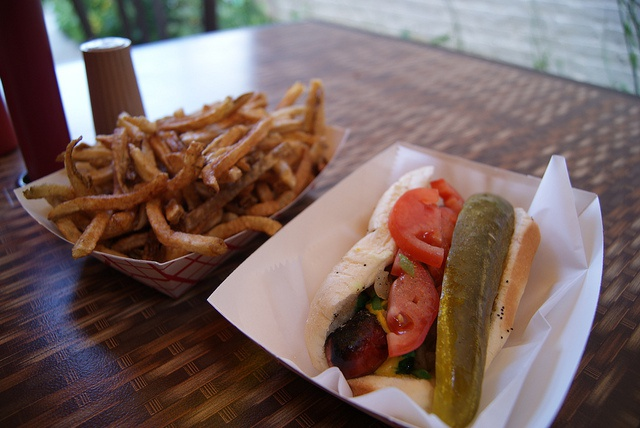Describe the objects in this image and their specific colors. I can see dining table in black, darkgray, maroon, and gray tones and sandwich in black, maroon, olive, and brown tones in this image. 